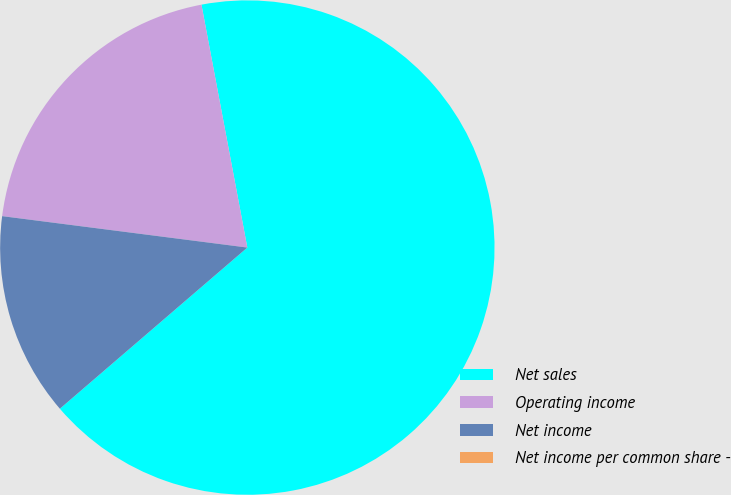Convert chart. <chart><loc_0><loc_0><loc_500><loc_500><pie_chart><fcel>Net sales<fcel>Operating income<fcel>Net income<fcel>Net income per common share -<nl><fcel>66.67%<fcel>20.0%<fcel>13.33%<fcel>0.0%<nl></chart> 